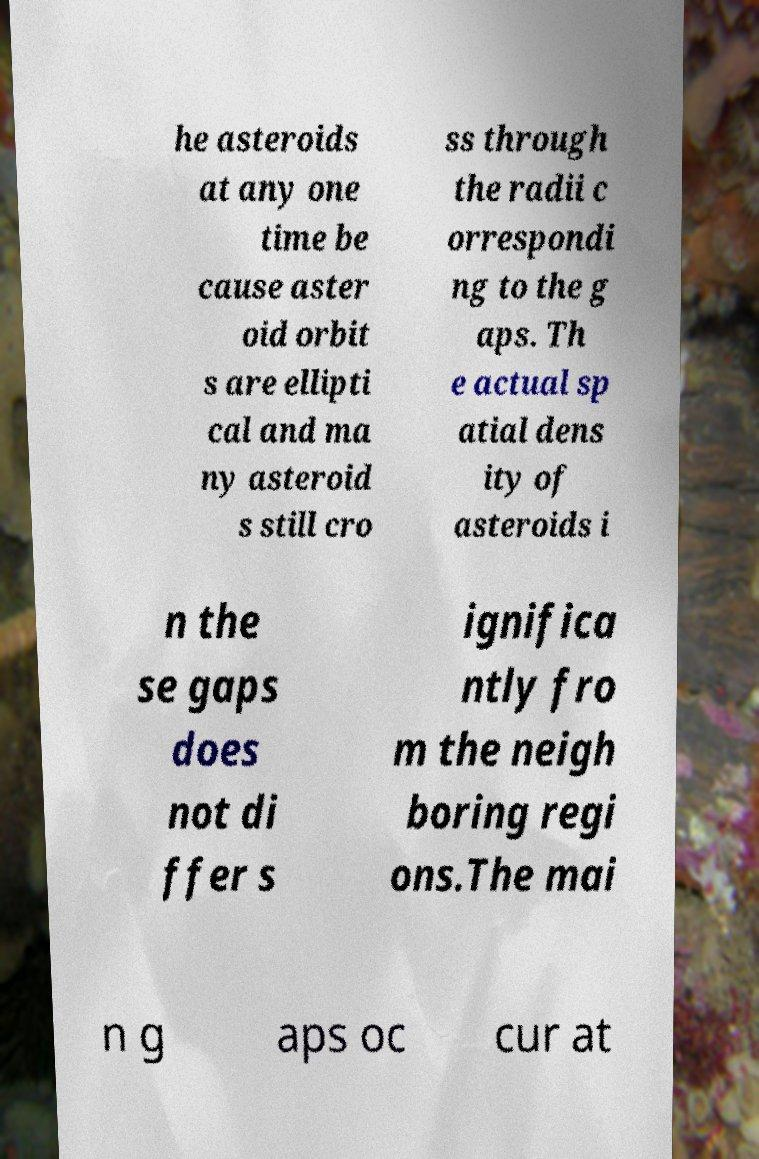What messages or text are displayed in this image? I need them in a readable, typed format. he asteroids at any one time be cause aster oid orbit s are ellipti cal and ma ny asteroid s still cro ss through the radii c orrespondi ng to the g aps. Th e actual sp atial dens ity of asteroids i n the se gaps does not di ffer s ignifica ntly fro m the neigh boring regi ons.The mai n g aps oc cur at 